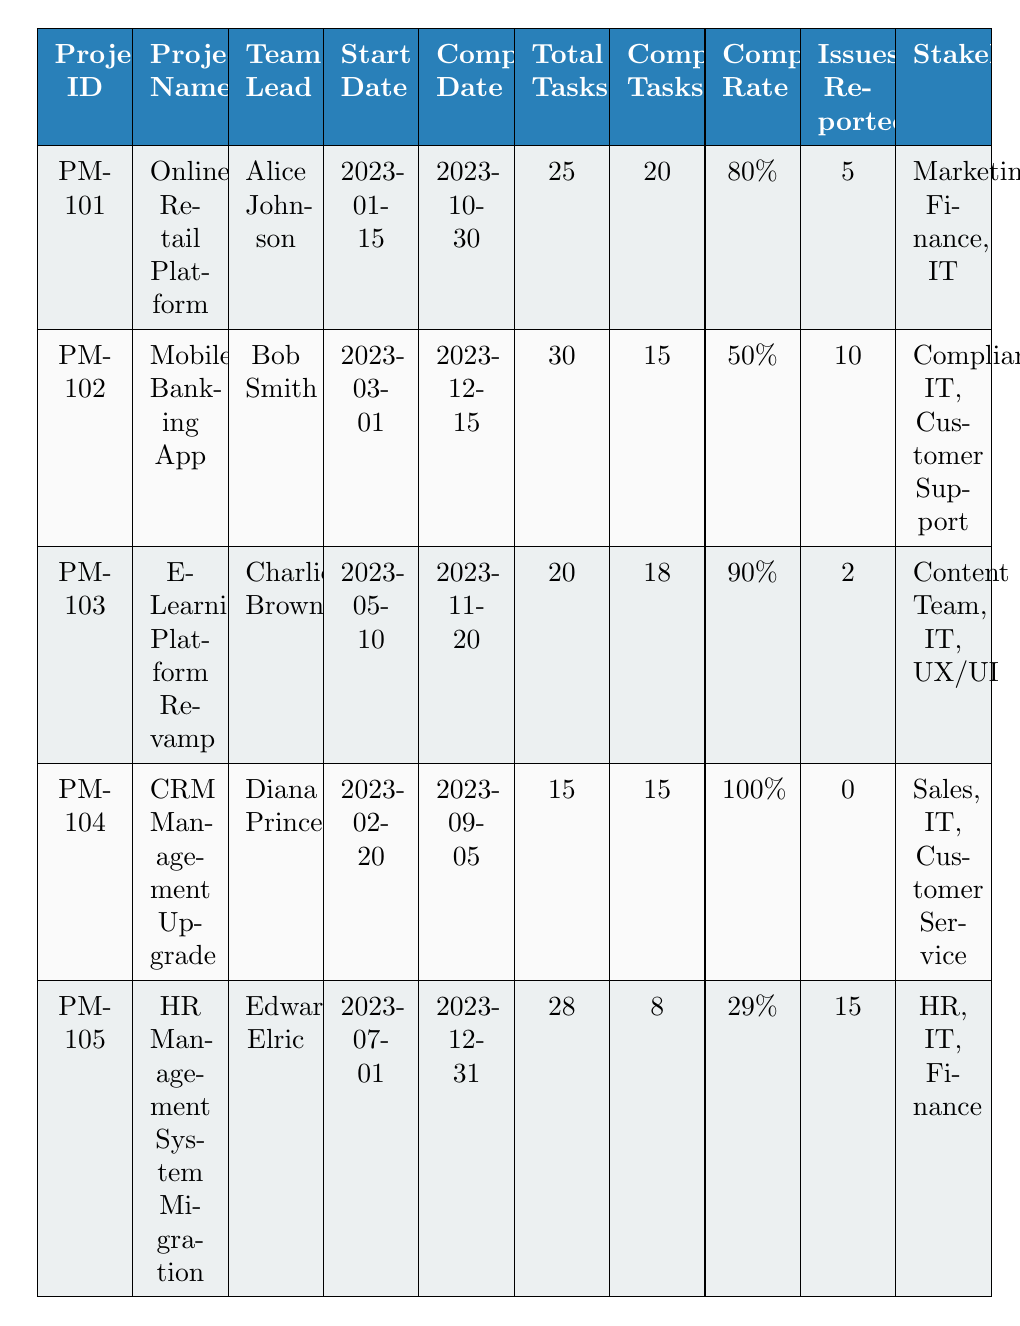What is the completion rate of the Online Retail Platform? The completion rate for the Online Retail Platform is specifically listed in the table under the "Completion Rate" column for the corresponding project ID "PM-101". It shows a completion rate of 80%.
Answer: 80% How many completed tasks are there in the Mobile Banking App? The table indicates the number of completed tasks for the Mobile Banking App under the "Completed Tasks" column for project ID "PM-102". It states that there are 15 completed tasks.
Answer: 15 Which project has the highest completion rate? By comparing the completion rates for all projects listed in the table, it is evident that the CRM Management Upgrade has a completion rate of 100%, which is higher than any other project.
Answer: CRM Management Upgrade What is the total number of issues reported across all projects? To find the total number of issues reported, we add the "Issues Reported" values for all projects: 5 + 10 + 2 + 0 + 15 = 32. Therefore, the total number of issues reported is 32.
Answer: 32 Is there a project with a completion rate below 30%? By examining the completion rates in the table, we see that the HR Management System Migration has a completion rate of 29%, which is below 30%.
Answer: Yes What is the difference in completed tasks between the E-Learning Platform Revamp and the HR Management System Migration? The completed tasks for the E-Learning Platform Revamp are 18, while for the HR Management System Migration they are 8. The difference is calculated as 18 - 8 = 10.
Answer: 10 How many stakeholders are involved in the Mobile Banking App project? The "Stakeholders" column for the Mobile Banking App project (PM-102) lists three stakeholders: Compliance, IT, and Customer Support. Hence, there are 3 stakeholders involved.
Answer: 3 What is the average completion rate of all projects? To compute the average completion rate, we sum up the completion rates (80% + 50% + 90% + 100% + 29%) = 349%. Then we divide by the number of projects (5), giving us an average rate of 69.8%.
Answer: 69.8% Which project started first in 2023? The start dates for all projects are compared, and the Online Retail Platform started on January 15, 2023, which is the earliest date mentioned in the table.
Answer: Online Retail Platform Which project reported the least number of issues? By closely reviewing the "Issues Reported" column, it’s clear that the CRM Management Upgrade reported 0 issues, which is the least reported among all projects.
Answer: CRM Management Upgrade 